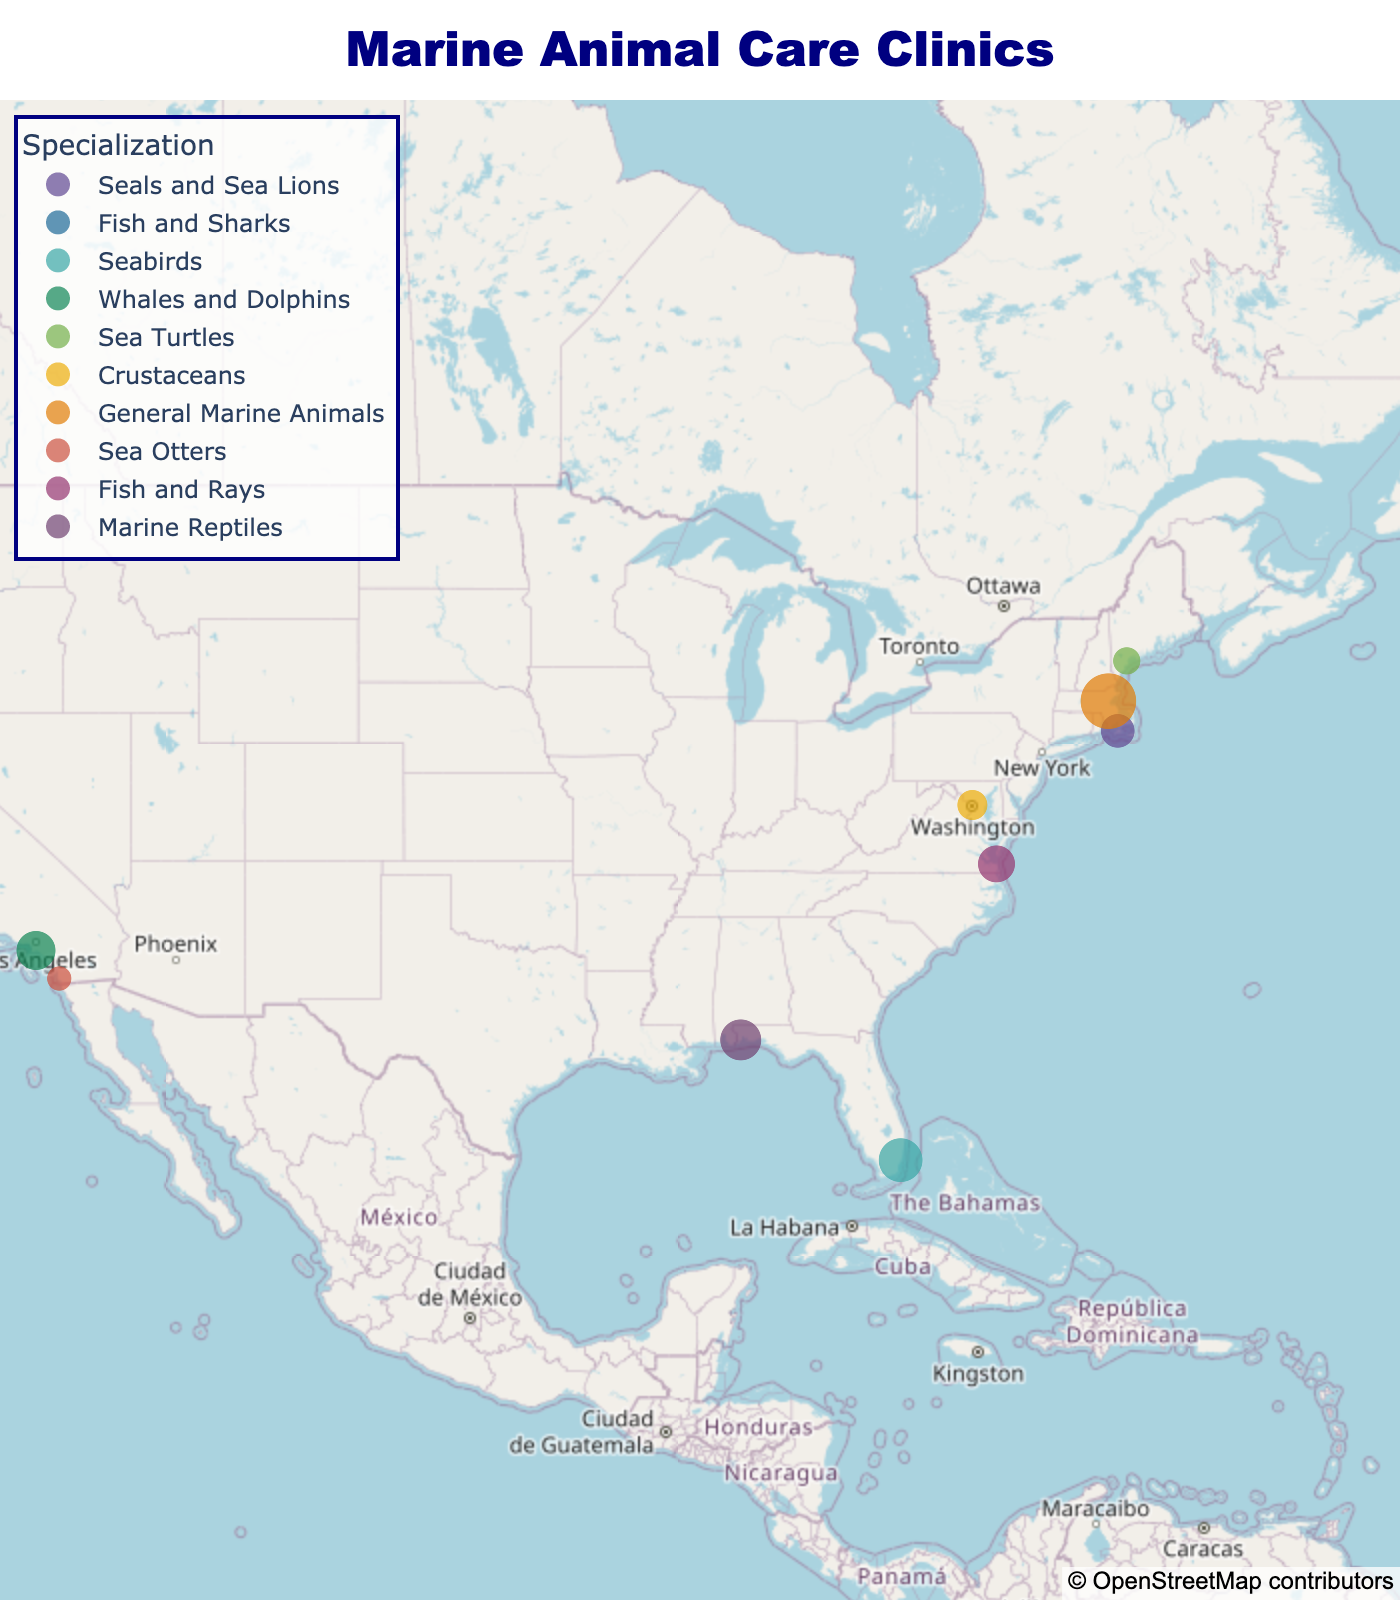What's the title of the figure? The title is located at the top center of the figure, usually in a larger and bolder font for better visibility.
Answer: Marine Animal Care Clinics Which clinic has the largest capacity? From the figure, hover over each point to find the hover data showing the clinic name and capacity. Compare them to find the highest.
Answer: Boston Harbor Marine Life Center How many clinics specialize in fish and rays? Identify the clinics by their specialization through the legend or hover over points to read their specializations. Count the clinics within that specific category.
Answer: 1 What is the total capacity of all clinics combined? Find the capacity of each clinic from the hover data, then sum up all these capacities: 15 + 30 + 25 + 20 + 10 + 12 + 40 + 8 + 18 + 22 = 200
Answer: 200 Which clinic is located furthest south? Check the latitude for all clinics by hovering over the points. The one with the smallest latitude number is the furthest south.
Answer: Miami Seabird Rescue Center Are there more clinics on the East Coast or the West Coast? Visually count the number of clinics along the East Coast of the USA and compare it with the number along the West Coast.
Answer: East Coast Which clinic has the lowest capacity? From the hover data on each point, compare the capacities to identify the smallest number.
Answer: San Diego Oceanfront Veterinary Clinic What's the average capacity for all clinics? Sum the capacities of all clinics and then divide by the number of clinics. The total capacity is 200, and there are 10 clinics. Therefore, 200/10 = 20
Answer: 20 